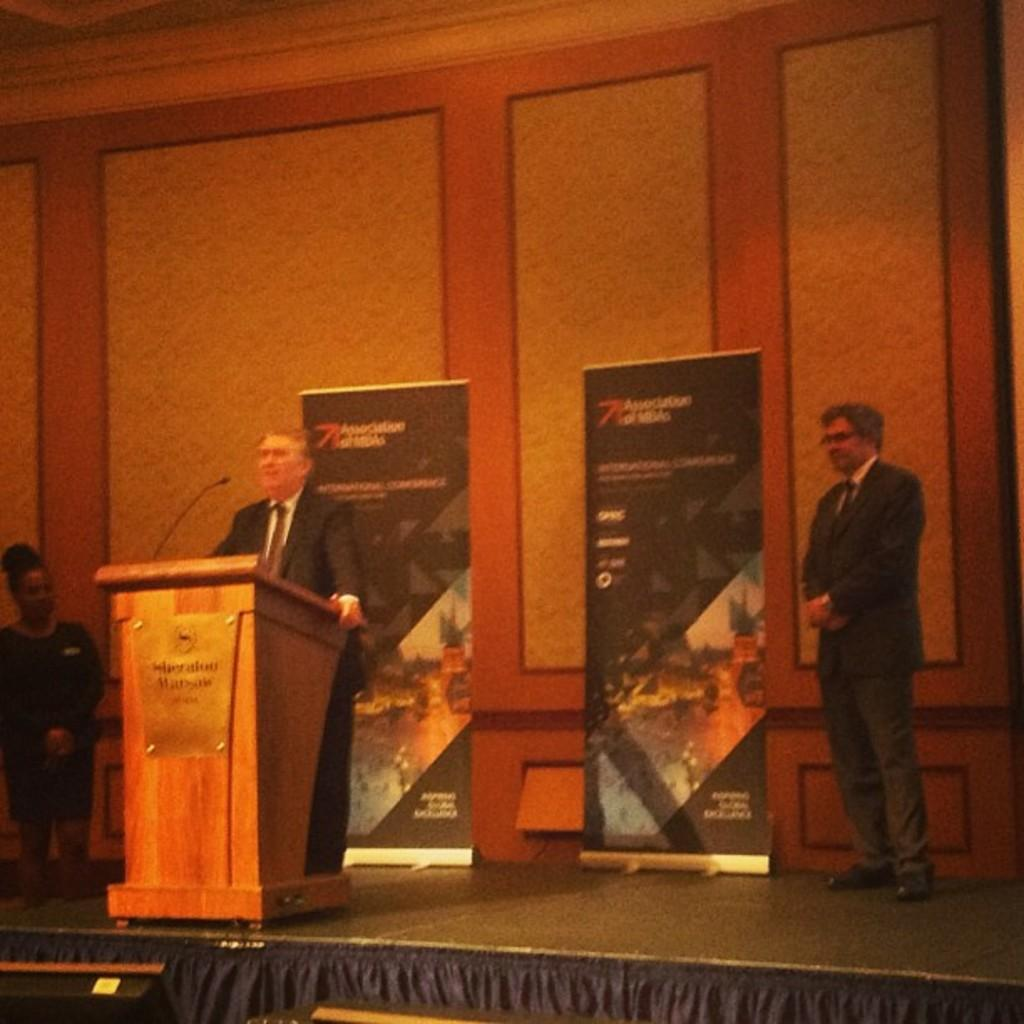How many people are in the image? There are three people in the image. Can you describe the gender of the people in the image? Two of them are men, and one of them is a woman. What is one of the men doing in the image? One of the men is standing in front of a podium. What can be seen in the background of the image? There is a wall in the background of the image. What committee is responsible for the measures discussed in the image? There is no committee or measures discussed in the image; it only shows three people, two of whom are men and one is a woman, with one man standing in front of a podium. 